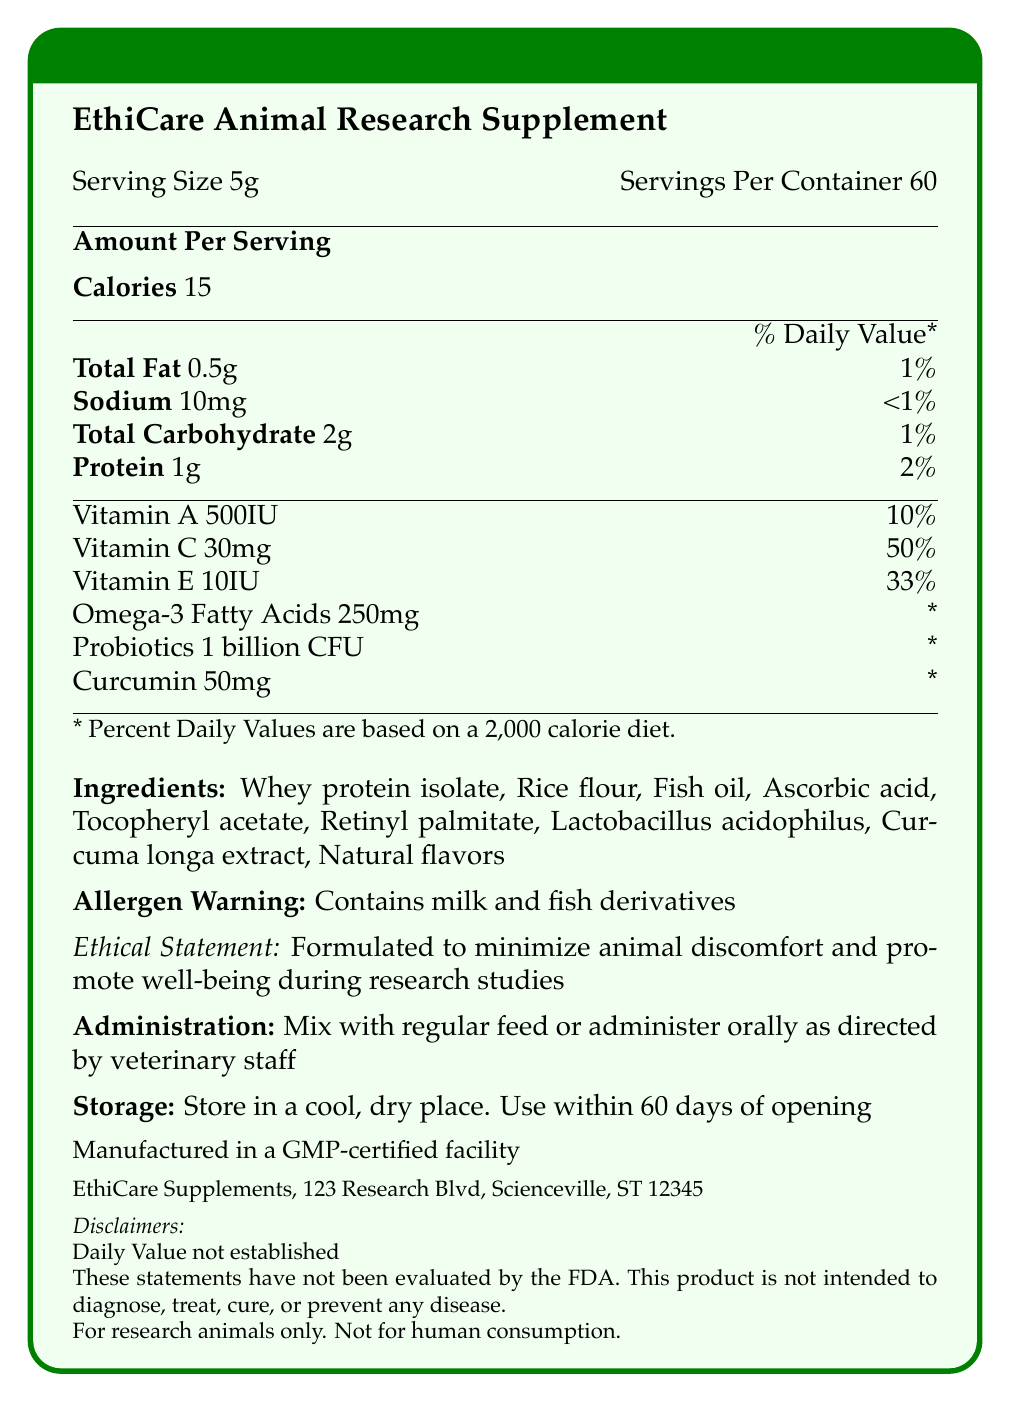what is the serving size? The document lists the serving size as 5 grams.
Answer: 5g how many servings are there per container? The document mentions that there are 60 servings per container.
Answer: 60 how many calories are in each serving? According to the document, each serving contains 15 calories.
Answer: 15 what percentage of the daily value is provided by the total fat per serving? The document specifies that the total fat per serving is 0.5g and provides 1% of the daily value.
Answer: 1% what ingredients are used in the supplement? The document lists the ingredients in the supplement.
Answer: Whey protein isolate, Rice flour, Fish oil, Ascorbic acid, Tocopheryl acetate, Retinyl palmitate, Lactobacillus acidophilus, Curcuma longa extract, Natural flavors what warning is provided on allergens? The allergen warning in the document states that the product contains milk and fish derivatives.
Answer: Contains milk and fish derivatives how should the supplement be administered? The administration instructions in the document specify how the supplement should be administered.
Answer: Mix with regular feed or administer orally as directed by veterinary staff what is the contact information for EthiCare Supplements? The document provides this contact information.
Answer: EthiCare Supplements, 123 Research Blvd, Scienceville, ST 12345 what is the percentage of the daily value for Vitamin C per serving? The document mentions that each serving provides 30mg of Vitamin C, which is 50% of the daily value.
Answer: 50% which vitamin is provided at 10% of the daily value per serving? The document states that each serving contains 500IU of Vitamin A, which is 10% of the daily value.
Answer: Vitamin A how long should the product be used after opening? A. 30 days B. 60 days C. 90 days D. 120 days The storage instructions mention that the product should be used within 60 days of opening.
Answer: B. 60 days which of the following is NOT listed as an ingredient? A. Rice flour B. Fish oil C. Chicken extract D. Natural flavors The document lists the ingredients but does not include chicken extract.
Answer: C. Chicken extract is the product intended for human consumption? The disclaimers clearly state that the product is for research animals only and not for human consumption.
Answer: No does the document mention that the product is manufactured in a GMP-certified facility? It is noted in the document that the product is manufactured in a GMP-certified facility.
Answer: Yes summarize the main idea of the document. The document's main idea revolves around offering comprehensive information about the supplement's nutritional content, administration guidelines, and ethical considerations to ensure minimal animal suffering during research.
Answer: The document provides detailed nutritional information for EthiCare Animal Research Supplement, including serving size, calorie content, and percentages of daily values for various nutrients. It also lists ingredients, allergen warnings, ethical statements, administration and storage instructions, disclaimers, and contact information. The supplement is designed to minimize animal discomfort during research. what are the potential health benefits of the probiotics in this supplement? The document lists probiotics (1 billion CFU) as an ingredient but does not elaborate on specific health benefits for research animals.
Answer: Not enough information 